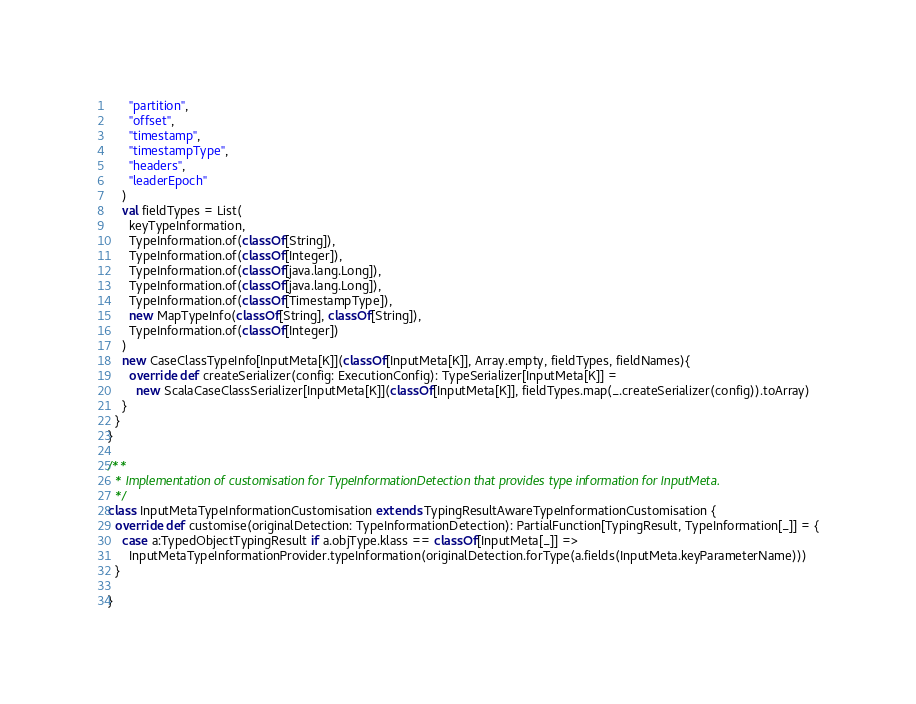Convert code to text. <code><loc_0><loc_0><loc_500><loc_500><_Scala_>      "partition",
      "offset",
      "timestamp",
      "timestampType",
      "headers",
      "leaderEpoch"
    )
    val fieldTypes = List(
      keyTypeInformation,
      TypeInformation.of(classOf[String]),
      TypeInformation.of(classOf[Integer]),
      TypeInformation.of(classOf[java.lang.Long]),
      TypeInformation.of(classOf[java.lang.Long]),
      TypeInformation.of(classOf[TimestampType]),
      new MapTypeInfo(classOf[String], classOf[String]),
      TypeInformation.of(classOf[Integer])
    )
    new CaseClassTypeInfo[InputMeta[K]](classOf[InputMeta[K]], Array.empty, fieldTypes, fieldNames){
      override def createSerializer(config: ExecutionConfig): TypeSerializer[InputMeta[K]] =
        new ScalaCaseClassSerializer[InputMeta[K]](classOf[InputMeta[K]], fieldTypes.map(_.createSerializer(config)).toArray)
    }
  }
}

/**
  * Implementation of customisation for TypeInformationDetection that provides type information for InputMeta.
  */
class InputMetaTypeInformationCustomisation extends TypingResultAwareTypeInformationCustomisation {
  override def customise(originalDetection: TypeInformationDetection): PartialFunction[TypingResult, TypeInformation[_]] = {
    case a:TypedObjectTypingResult if a.objType.klass == classOf[InputMeta[_]] =>
      InputMetaTypeInformationProvider.typeInformation(originalDetection.forType(a.fields(InputMeta.keyParameterName)))
  }

}</code> 